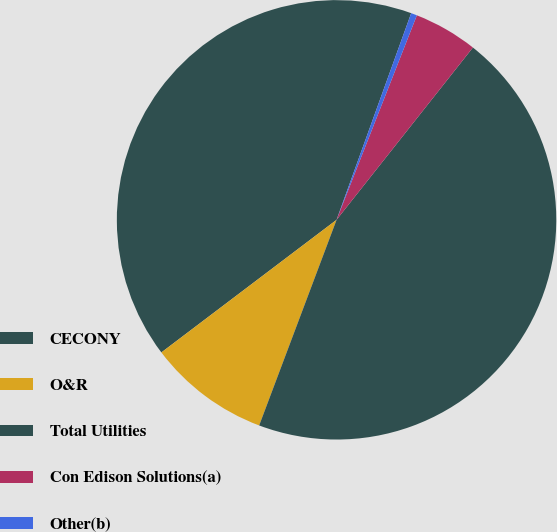Convert chart. <chart><loc_0><loc_0><loc_500><loc_500><pie_chart><fcel>CECONY<fcel>O&R<fcel>Total Utilities<fcel>Con Edison Solutions(a)<fcel>Other(b)<nl><fcel>40.83%<fcel>8.96%<fcel>45.08%<fcel>4.7%<fcel>0.44%<nl></chart> 